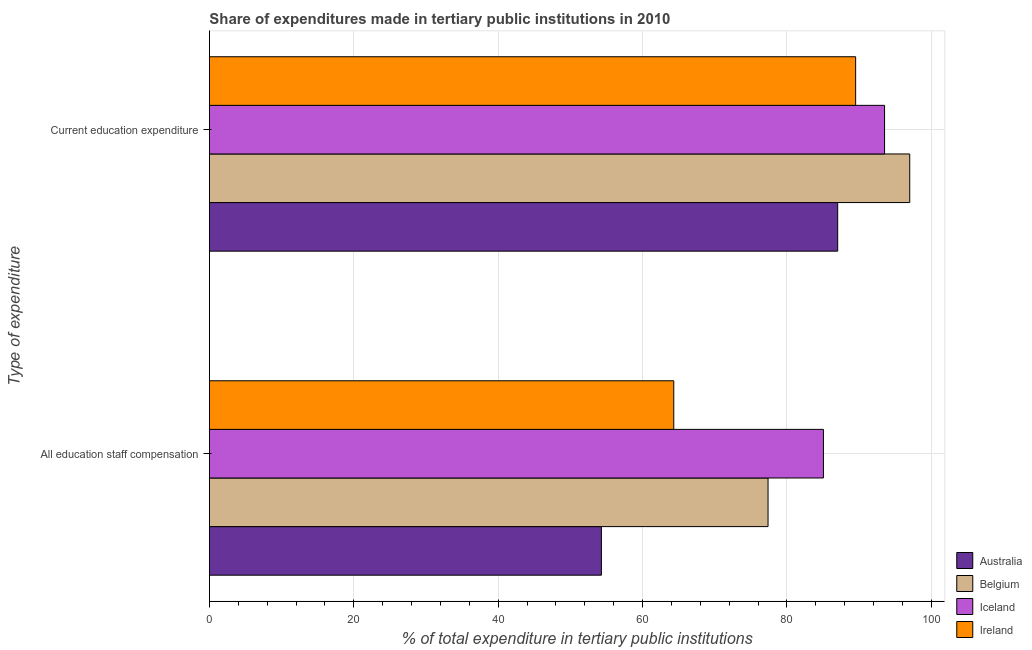Are the number of bars per tick equal to the number of legend labels?
Give a very brief answer. Yes. Are the number of bars on each tick of the Y-axis equal?
Provide a short and direct response. Yes. How many bars are there on the 2nd tick from the top?
Keep it short and to the point. 4. What is the label of the 1st group of bars from the top?
Offer a very short reply. Current education expenditure. What is the expenditure in staff compensation in Belgium?
Your response must be concise. 77.38. Across all countries, what is the maximum expenditure in staff compensation?
Your answer should be very brief. 85.05. Across all countries, what is the minimum expenditure in education?
Provide a short and direct response. 87.02. In which country was the expenditure in staff compensation maximum?
Give a very brief answer. Iceland. In which country was the expenditure in education minimum?
Your response must be concise. Australia. What is the total expenditure in staff compensation in the graph?
Offer a very short reply. 281.04. What is the difference between the expenditure in staff compensation in Belgium and that in Ireland?
Provide a short and direct response. 13.06. What is the difference between the expenditure in staff compensation in Iceland and the expenditure in education in Ireland?
Provide a short and direct response. -4.46. What is the average expenditure in education per country?
Ensure brevity in your answer.  91.76. What is the difference between the expenditure in staff compensation and expenditure in education in Ireland?
Give a very brief answer. -25.19. What is the ratio of the expenditure in staff compensation in Iceland to that in Belgium?
Offer a very short reply. 1.1. Is the expenditure in staff compensation in Ireland less than that in Australia?
Offer a very short reply. No. In how many countries, is the expenditure in education greater than the average expenditure in education taken over all countries?
Offer a very short reply. 2. What does the 2nd bar from the top in Current education expenditure represents?
Make the answer very short. Iceland. Are all the bars in the graph horizontal?
Keep it short and to the point. Yes. Are the values on the major ticks of X-axis written in scientific E-notation?
Your answer should be very brief. No. Does the graph contain any zero values?
Your answer should be compact. No. Where does the legend appear in the graph?
Offer a very short reply. Bottom right. How many legend labels are there?
Make the answer very short. 4. How are the legend labels stacked?
Give a very brief answer. Vertical. What is the title of the graph?
Give a very brief answer. Share of expenditures made in tertiary public institutions in 2010. Does "Norway" appear as one of the legend labels in the graph?
Provide a succinct answer. No. What is the label or title of the X-axis?
Your response must be concise. % of total expenditure in tertiary public institutions. What is the label or title of the Y-axis?
Your response must be concise. Type of expenditure. What is the % of total expenditure in tertiary public institutions in Australia in All education staff compensation?
Ensure brevity in your answer.  54.29. What is the % of total expenditure in tertiary public institutions of Belgium in All education staff compensation?
Offer a terse response. 77.38. What is the % of total expenditure in tertiary public institutions in Iceland in All education staff compensation?
Offer a very short reply. 85.05. What is the % of total expenditure in tertiary public institutions in Ireland in All education staff compensation?
Give a very brief answer. 64.32. What is the % of total expenditure in tertiary public institutions in Australia in Current education expenditure?
Make the answer very short. 87.02. What is the % of total expenditure in tertiary public institutions in Belgium in Current education expenditure?
Offer a terse response. 97. What is the % of total expenditure in tertiary public institutions in Iceland in Current education expenditure?
Offer a terse response. 93.52. What is the % of total expenditure in tertiary public institutions of Ireland in Current education expenditure?
Provide a succinct answer. 89.51. Across all Type of expenditure, what is the maximum % of total expenditure in tertiary public institutions of Australia?
Make the answer very short. 87.02. Across all Type of expenditure, what is the maximum % of total expenditure in tertiary public institutions in Belgium?
Offer a terse response. 97. Across all Type of expenditure, what is the maximum % of total expenditure in tertiary public institutions of Iceland?
Keep it short and to the point. 93.52. Across all Type of expenditure, what is the maximum % of total expenditure in tertiary public institutions of Ireland?
Provide a short and direct response. 89.51. Across all Type of expenditure, what is the minimum % of total expenditure in tertiary public institutions of Australia?
Ensure brevity in your answer.  54.29. Across all Type of expenditure, what is the minimum % of total expenditure in tertiary public institutions in Belgium?
Make the answer very short. 77.38. Across all Type of expenditure, what is the minimum % of total expenditure in tertiary public institutions in Iceland?
Give a very brief answer. 85.05. Across all Type of expenditure, what is the minimum % of total expenditure in tertiary public institutions in Ireland?
Make the answer very short. 64.32. What is the total % of total expenditure in tertiary public institutions of Australia in the graph?
Keep it short and to the point. 141.32. What is the total % of total expenditure in tertiary public institutions of Belgium in the graph?
Your answer should be very brief. 174.38. What is the total % of total expenditure in tertiary public institutions of Iceland in the graph?
Make the answer very short. 178.57. What is the total % of total expenditure in tertiary public institutions of Ireland in the graph?
Offer a terse response. 153.83. What is the difference between the % of total expenditure in tertiary public institutions in Australia in All education staff compensation and that in Current education expenditure?
Keep it short and to the point. -32.73. What is the difference between the % of total expenditure in tertiary public institutions of Belgium in All education staff compensation and that in Current education expenditure?
Give a very brief answer. -19.63. What is the difference between the % of total expenditure in tertiary public institutions in Iceland in All education staff compensation and that in Current education expenditure?
Offer a very short reply. -8.47. What is the difference between the % of total expenditure in tertiary public institutions of Ireland in All education staff compensation and that in Current education expenditure?
Offer a terse response. -25.19. What is the difference between the % of total expenditure in tertiary public institutions of Australia in All education staff compensation and the % of total expenditure in tertiary public institutions of Belgium in Current education expenditure?
Your response must be concise. -42.71. What is the difference between the % of total expenditure in tertiary public institutions in Australia in All education staff compensation and the % of total expenditure in tertiary public institutions in Iceland in Current education expenditure?
Offer a terse response. -39.22. What is the difference between the % of total expenditure in tertiary public institutions in Australia in All education staff compensation and the % of total expenditure in tertiary public institutions in Ireland in Current education expenditure?
Give a very brief answer. -35.22. What is the difference between the % of total expenditure in tertiary public institutions of Belgium in All education staff compensation and the % of total expenditure in tertiary public institutions of Iceland in Current education expenditure?
Your response must be concise. -16.14. What is the difference between the % of total expenditure in tertiary public institutions in Belgium in All education staff compensation and the % of total expenditure in tertiary public institutions in Ireland in Current education expenditure?
Your answer should be very brief. -12.13. What is the difference between the % of total expenditure in tertiary public institutions in Iceland in All education staff compensation and the % of total expenditure in tertiary public institutions in Ireland in Current education expenditure?
Your answer should be very brief. -4.46. What is the average % of total expenditure in tertiary public institutions in Australia per Type of expenditure?
Make the answer very short. 70.66. What is the average % of total expenditure in tertiary public institutions of Belgium per Type of expenditure?
Give a very brief answer. 87.19. What is the average % of total expenditure in tertiary public institutions in Iceland per Type of expenditure?
Offer a very short reply. 89.28. What is the average % of total expenditure in tertiary public institutions of Ireland per Type of expenditure?
Offer a very short reply. 76.91. What is the difference between the % of total expenditure in tertiary public institutions of Australia and % of total expenditure in tertiary public institutions of Belgium in All education staff compensation?
Ensure brevity in your answer.  -23.08. What is the difference between the % of total expenditure in tertiary public institutions in Australia and % of total expenditure in tertiary public institutions in Iceland in All education staff compensation?
Provide a succinct answer. -30.75. What is the difference between the % of total expenditure in tertiary public institutions of Australia and % of total expenditure in tertiary public institutions of Ireland in All education staff compensation?
Keep it short and to the point. -10.03. What is the difference between the % of total expenditure in tertiary public institutions of Belgium and % of total expenditure in tertiary public institutions of Iceland in All education staff compensation?
Give a very brief answer. -7.67. What is the difference between the % of total expenditure in tertiary public institutions of Belgium and % of total expenditure in tertiary public institutions of Ireland in All education staff compensation?
Keep it short and to the point. 13.06. What is the difference between the % of total expenditure in tertiary public institutions in Iceland and % of total expenditure in tertiary public institutions in Ireland in All education staff compensation?
Provide a short and direct response. 20.73. What is the difference between the % of total expenditure in tertiary public institutions in Australia and % of total expenditure in tertiary public institutions in Belgium in Current education expenditure?
Make the answer very short. -9.98. What is the difference between the % of total expenditure in tertiary public institutions in Australia and % of total expenditure in tertiary public institutions in Iceland in Current education expenditure?
Your answer should be compact. -6.49. What is the difference between the % of total expenditure in tertiary public institutions in Australia and % of total expenditure in tertiary public institutions in Ireland in Current education expenditure?
Keep it short and to the point. -2.49. What is the difference between the % of total expenditure in tertiary public institutions in Belgium and % of total expenditure in tertiary public institutions in Iceland in Current education expenditure?
Make the answer very short. 3.49. What is the difference between the % of total expenditure in tertiary public institutions in Belgium and % of total expenditure in tertiary public institutions in Ireland in Current education expenditure?
Ensure brevity in your answer.  7.49. What is the difference between the % of total expenditure in tertiary public institutions in Iceland and % of total expenditure in tertiary public institutions in Ireland in Current education expenditure?
Keep it short and to the point. 4.01. What is the ratio of the % of total expenditure in tertiary public institutions of Australia in All education staff compensation to that in Current education expenditure?
Your answer should be compact. 0.62. What is the ratio of the % of total expenditure in tertiary public institutions of Belgium in All education staff compensation to that in Current education expenditure?
Keep it short and to the point. 0.8. What is the ratio of the % of total expenditure in tertiary public institutions of Iceland in All education staff compensation to that in Current education expenditure?
Provide a short and direct response. 0.91. What is the ratio of the % of total expenditure in tertiary public institutions in Ireland in All education staff compensation to that in Current education expenditure?
Your response must be concise. 0.72. What is the difference between the highest and the second highest % of total expenditure in tertiary public institutions in Australia?
Offer a very short reply. 32.73. What is the difference between the highest and the second highest % of total expenditure in tertiary public institutions in Belgium?
Give a very brief answer. 19.63. What is the difference between the highest and the second highest % of total expenditure in tertiary public institutions in Iceland?
Offer a terse response. 8.47. What is the difference between the highest and the second highest % of total expenditure in tertiary public institutions of Ireland?
Ensure brevity in your answer.  25.19. What is the difference between the highest and the lowest % of total expenditure in tertiary public institutions in Australia?
Offer a terse response. 32.73. What is the difference between the highest and the lowest % of total expenditure in tertiary public institutions of Belgium?
Offer a very short reply. 19.63. What is the difference between the highest and the lowest % of total expenditure in tertiary public institutions of Iceland?
Your answer should be compact. 8.47. What is the difference between the highest and the lowest % of total expenditure in tertiary public institutions of Ireland?
Ensure brevity in your answer.  25.19. 